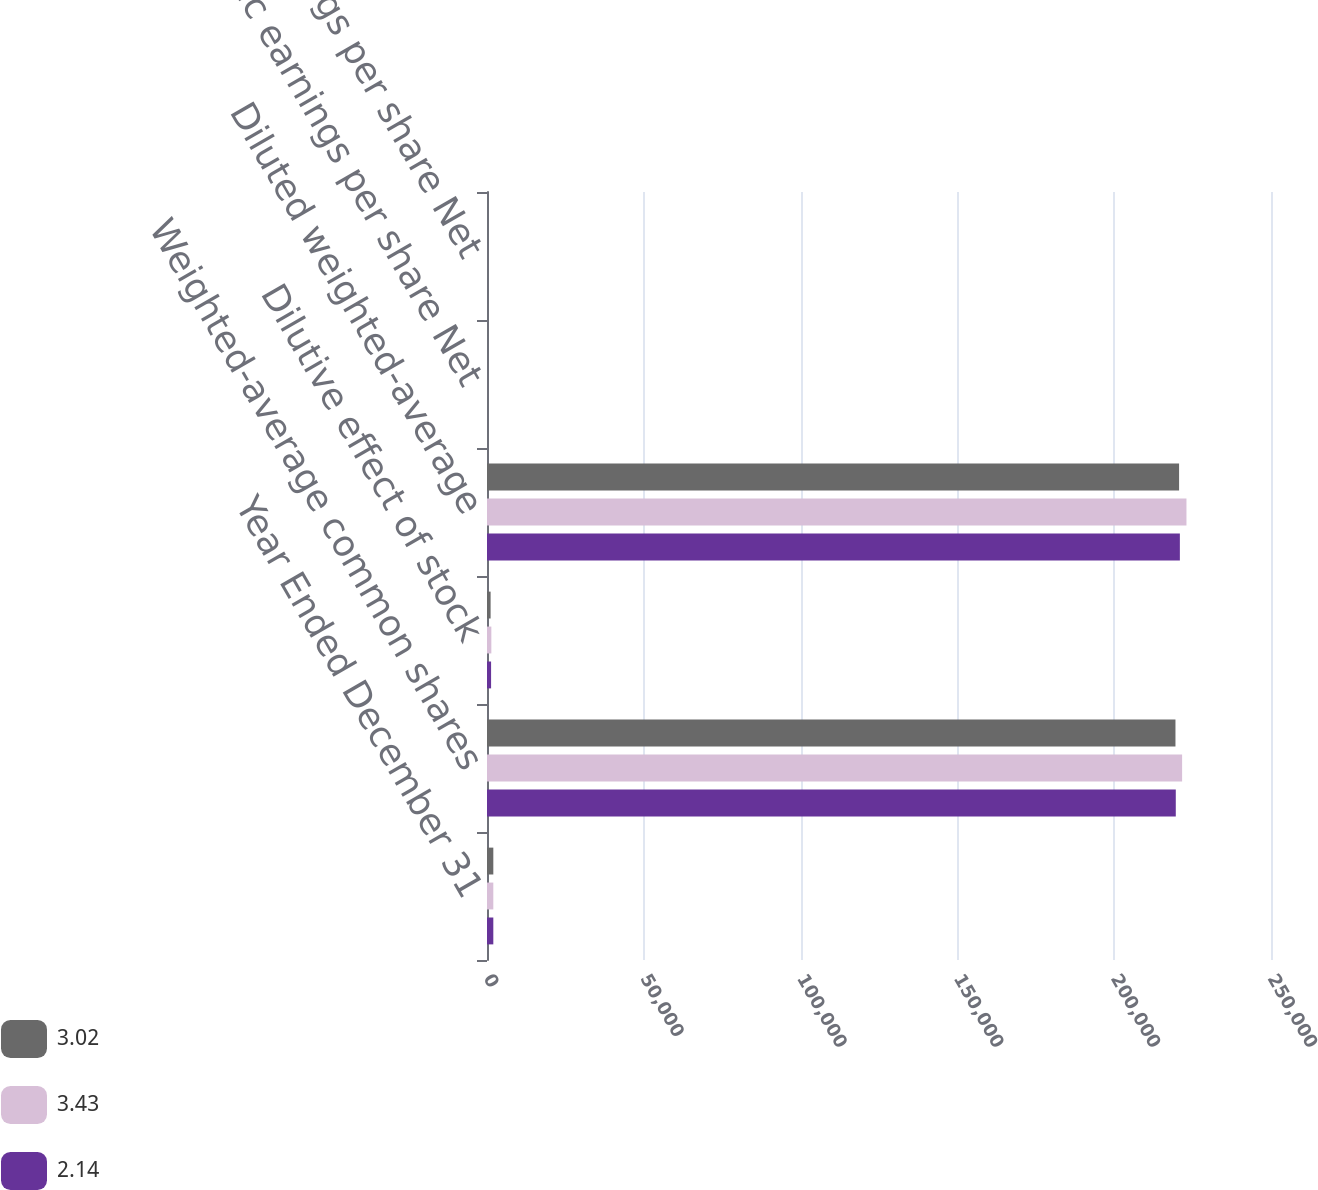Convert chart. <chart><loc_0><loc_0><loc_500><loc_500><stacked_bar_chart><ecel><fcel>Year Ended December 31<fcel>Weighted-average common shares<fcel>Dilutive effect of stock<fcel>Diluted weighted-average<fcel>Basic earnings per share Net<fcel>Diluted earnings per share Net<nl><fcel>3.02<fcel>2015<fcel>219537<fcel>1152<fcel>220689<fcel>3.03<fcel>3.02<nl><fcel>3.43<fcel>2014<fcel>221658<fcel>1386<fcel>223044<fcel>3.45<fcel>3.43<nl><fcel>2.14<fcel>2013<fcel>219638<fcel>1303<fcel>220941<fcel>2.16<fcel>2.14<nl></chart> 